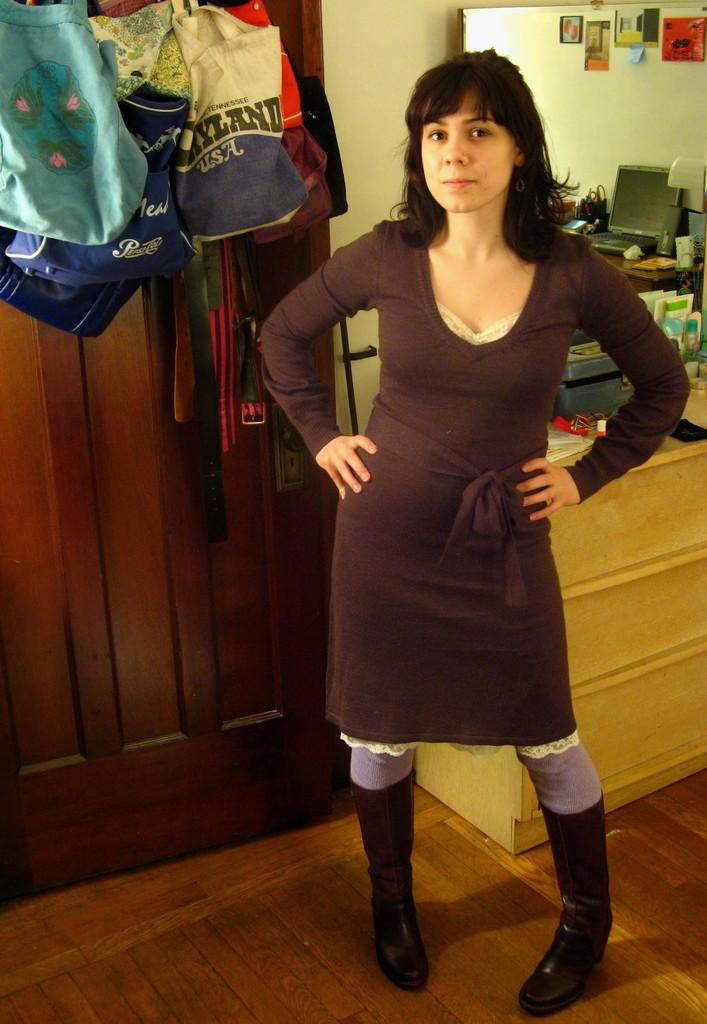<image>
Render a clear and concise summary of the photo. A woman wearing a brown dress stands in front of a bag that says USA on it 